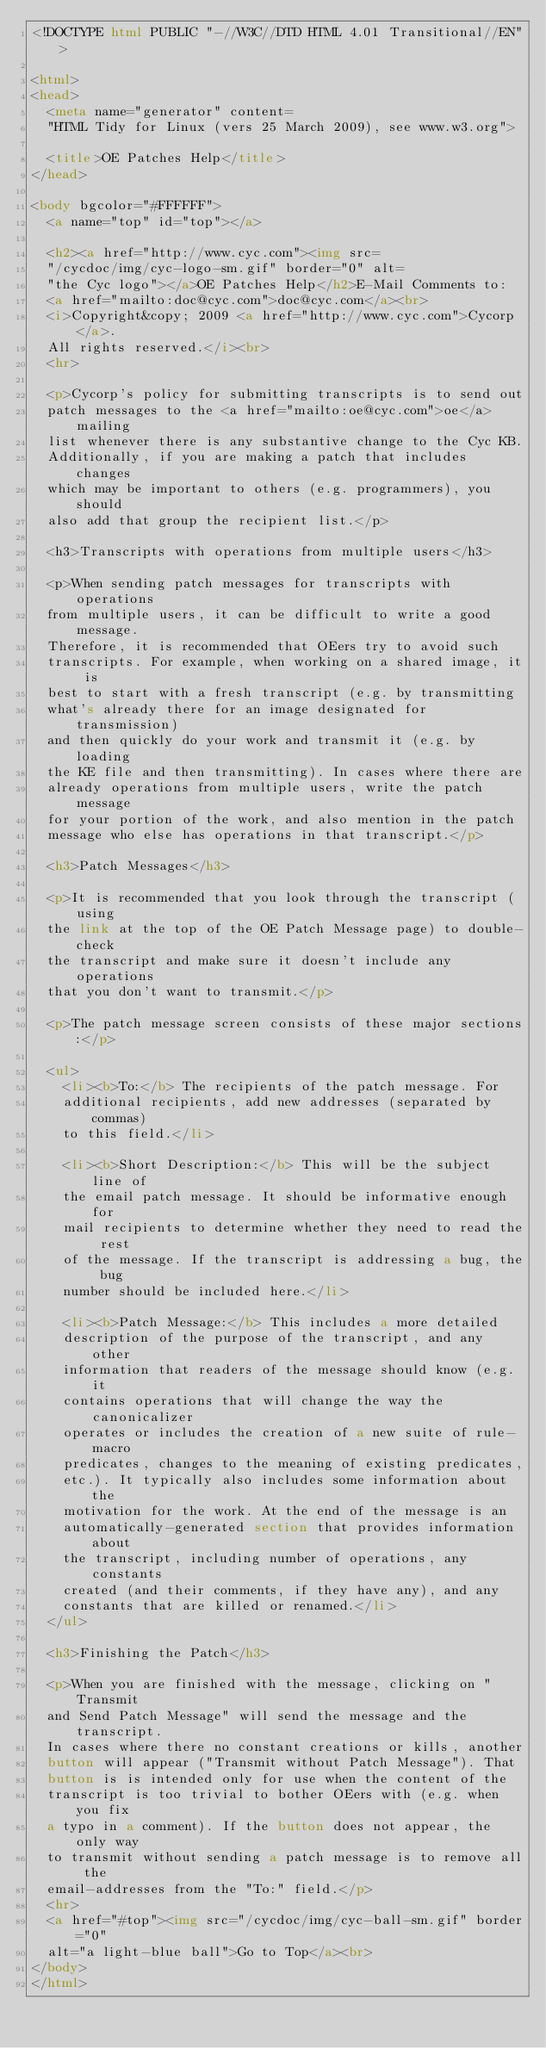Convert code to text. <code><loc_0><loc_0><loc_500><loc_500><_HTML_><!DOCTYPE html PUBLIC "-//W3C//DTD HTML 4.01 Transitional//EN">

<html>
<head>
  <meta name="generator" content=
  "HTML Tidy for Linux (vers 25 March 2009), see www.w3.org">

  <title>OE Patches Help</title>
</head>

<body bgcolor="#FFFFFF">
  <a name="top" id="top"></a>

  <h2><a href="http://www.cyc.com"><img src=
  "/cycdoc/img/cyc-logo-sm.gif" border="0" alt=
  "the Cyc logo"></a>OE Patches Help</h2>E-Mail Comments to:
  <a href="mailto:doc@cyc.com">doc@cyc.com</a><br>
  <i>Copyright&copy; 2009 <a href="http://www.cyc.com">Cycorp</a>.
  All rights reserved.</i><br>
  <hr>

  <p>Cycorp's policy for submitting transcripts is to send out
  patch messages to the <a href="mailto:oe@cyc.com">oe</a> mailing
  list whenever there is any substantive change to the Cyc KB.
  Additionally, if you are making a patch that includes changes
  which may be important to others (e.g. programmers), you should
  also add that group the recipient list.</p>

  <h3>Transcripts with operations from multiple users</h3>

  <p>When sending patch messages for transcripts with operations
  from multiple users, it can be difficult to write a good message.
  Therefore, it is recommended that OEers try to avoid such
  transcripts. For example, when working on a shared image, it is
  best to start with a fresh transcript (e.g. by transmitting
  what's already there for an image designated for transmission)
  and then quickly do your work and transmit it (e.g. by loading
  the KE file and then transmitting). In cases where there are
  already operations from multiple users, write the patch message
  for your portion of the work, and also mention in the patch
  message who else has operations in that transcript.</p>

  <h3>Patch Messages</h3>

  <p>It is recommended that you look through the transcript (using
  the link at the top of the OE Patch Message page) to double-check
  the transcript and make sure it doesn't include any operations
  that you don't want to transmit.</p>

  <p>The patch message screen consists of these major sections:</p>

  <ul>
    <li><b>To:</b> The recipients of the patch message. For
    additional recipients, add new addresses (separated by commas)
    to this field.</li>

    <li><b>Short Description:</b> This will be the subject line of
    the email patch message. It should be informative enough for
    mail recipients to determine whether they need to read the rest
    of the message. If the transcript is addressing a bug, the bug
    number should be included here.</li>

    <li><b>Patch Message:</b> This includes a more detailed
    description of the purpose of the transcript, and any other
    information that readers of the message should know (e.g. it
    contains operations that will change the way the canonicalizer
    operates or includes the creation of a new suite of rule-macro
    predicates, changes to the meaning of existing predicates,
    etc.). It typically also includes some information about the
    motivation for the work. At the end of the message is an
    automatically-generated section that provides information about
    the transcript, including number of operations, any constants
    created (and their comments, if they have any), and any
    constants that are killed or renamed.</li>
  </ul>

  <h3>Finishing the Patch</h3>

  <p>When you are finished with the message, clicking on "Transmit
  and Send Patch Message" will send the message and the transcript.
  In cases where there no constant creations or kills, another
  button will appear ("Transmit without Patch Message"). That
  button is is intended only for use when the content of the
  transcript is too trivial to bother OEers with (e.g. when you fix
  a typo in a comment). If the button does not appear, the only way
  to transmit without sending a patch message is to remove all the
  email-addresses from the "To:" field.</p>
  <hr>
  <a href="#top"><img src="/cycdoc/img/cyc-ball-sm.gif" border="0"
  alt="a light-blue ball">Go to Top</a><br>
</body>
</html>
</code> 